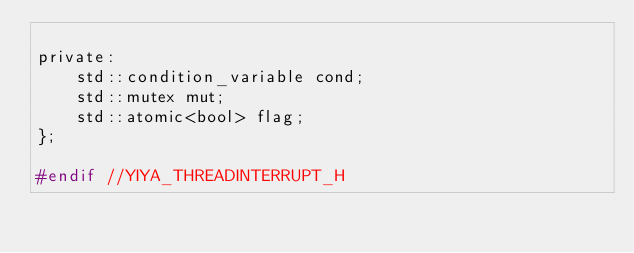Convert code to text. <code><loc_0><loc_0><loc_500><loc_500><_C_>
private:
    std::condition_variable cond;
    std::mutex mut;
    std::atomic<bool> flag;
};

#endif //YIYA_THREADINTERRUPT_H
</code> 